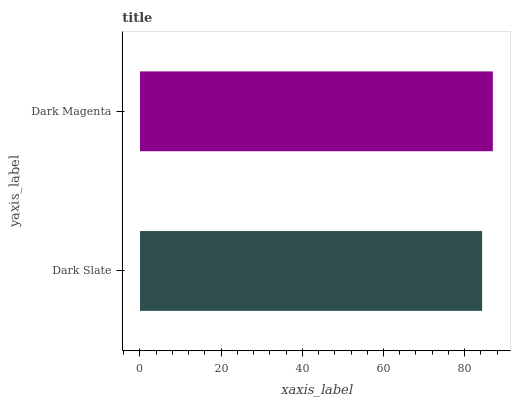Is Dark Slate the minimum?
Answer yes or no. Yes. Is Dark Magenta the maximum?
Answer yes or no. Yes. Is Dark Magenta the minimum?
Answer yes or no. No. Is Dark Magenta greater than Dark Slate?
Answer yes or no. Yes. Is Dark Slate less than Dark Magenta?
Answer yes or no. Yes. Is Dark Slate greater than Dark Magenta?
Answer yes or no. No. Is Dark Magenta less than Dark Slate?
Answer yes or no. No. Is Dark Magenta the high median?
Answer yes or no. Yes. Is Dark Slate the low median?
Answer yes or no. Yes. Is Dark Slate the high median?
Answer yes or no. No. Is Dark Magenta the low median?
Answer yes or no. No. 